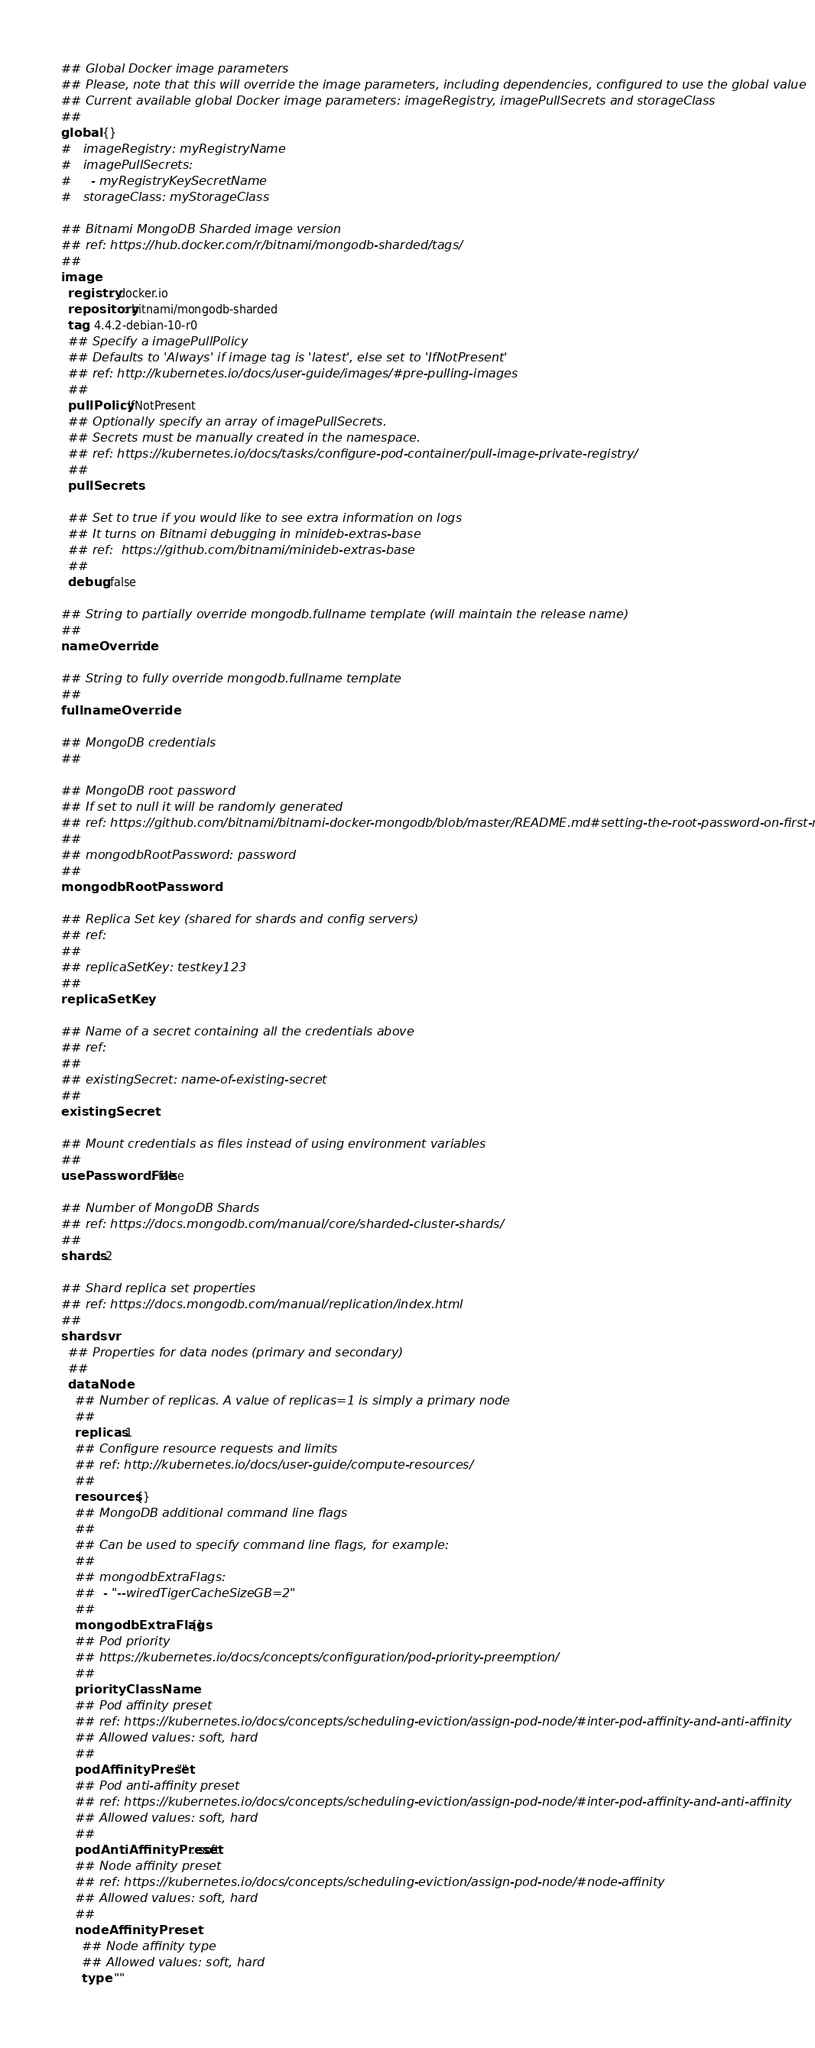Convert code to text. <code><loc_0><loc_0><loc_500><loc_500><_YAML_>## Global Docker image parameters
## Please, note that this will override the image parameters, including dependencies, configured to use the global value
## Current available global Docker image parameters: imageRegistry, imagePullSecrets and storageClass
##
global: {}
#   imageRegistry: myRegistryName
#   imagePullSecrets:
#     - myRegistryKeySecretName
#   storageClass: myStorageClass

## Bitnami MongoDB Sharded image version
## ref: https://hub.docker.com/r/bitnami/mongodb-sharded/tags/
##
image:
  registry: docker.io
  repository: bitnami/mongodb-sharded
  tag: 4.4.2-debian-10-r0
  ## Specify a imagePullPolicy
  ## Defaults to 'Always' if image tag is 'latest', else set to 'IfNotPresent'
  ## ref: http://kubernetes.io/docs/user-guide/images/#pre-pulling-images
  ##
  pullPolicy: IfNotPresent
  ## Optionally specify an array of imagePullSecrets.
  ## Secrets must be manually created in the namespace.
  ## ref: https://kubernetes.io/docs/tasks/configure-pod-container/pull-image-private-registry/
  ##
  pullSecrets:

  ## Set to true if you would like to see extra information on logs
  ## It turns on Bitnami debugging in minideb-extras-base
  ## ref:  https://github.com/bitnami/minideb-extras-base
  ##
  debug: false

## String to partially override mongodb.fullname template (will maintain the release name)
##
nameOverride:

## String to fully override mongodb.fullname template
##
fullnameOverride:

## MongoDB credentials
##

## MongoDB root password
## If set to null it will be randomly generated
## ref: https://github.com/bitnami/bitnami-docker-mongodb/blob/master/README.md#setting-the-root-password-on-first-run
##
## mongodbRootPassword: password
##
mongodbRootPassword:

## Replica Set key (shared for shards and config servers)
## ref:
##
## replicaSetKey: testkey123
##
replicaSetKey:

## Name of a secret containing all the credentials above
## ref:
##
## existingSecret: name-of-existing-secret
##
existingSecret:

## Mount credentials as files instead of using environment variables
##
usePasswordFile: false

## Number of MongoDB Shards
## ref: https://docs.mongodb.com/manual/core/sharded-cluster-shards/
##
shards: 2

## Shard replica set properties
## ref: https://docs.mongodb.com/manual/replication/index.html
##
shardsvr:
  ## Properties for data nodes (primary and secondary)
  ##
  dataNode:
    ## Number of replicas. A value of replicas=1 is simply a primary node
    ##
    replicas: 1
    ## Configure resource requests and limits
    ## ref: http://kubernetes.io/docs/user-guide/compute-resources/
    ##
    resources: {}
    ## MongoDB additional command line flags
    ##
    ## Can be used to specify command line flags, for example:
    ##
    ## mongodbExtraFlags:
    ##  - "--wiredTigerCacheSizeGB=2"
    ##
    mongodbExtraFlags: []
    ## Pod priority
    ## https://kubernetes.io/docs/concepts/configuration/pod-priority-preemption/
    ##
    priorityClassName:
    ## Pod affinity preset
    ## ref: https://kubernetes.io/docs/concepts/scheduling-eviction/assign-pod-node/#inter-pod-affinity-and-anti-affinity
    ## Allowed values: soft, hard
    ##
    podAffinityPreset: ""
    ## Pod anti-affinity preset
    ## ref: https://kubernetes.io/docs/concepts/scheduling-eviction/assign-pod-node/#inter-pod-affinity-and-anti-affinity
    ## Allowed values: soft, hard
    ##
    podAntiAffinityPreset: soft
    ## Node affinity preset
    ## ref: https://kubernetes.io/docs/concepts/scheduling-eviction/assign-pod-node/#node-affinity
    ## Allowed values: soft, hard
    ##
    nodeAffinityPreset:
      ## Node affinity type
      ## Allowed values: soft, hard
      type: ""</code> 